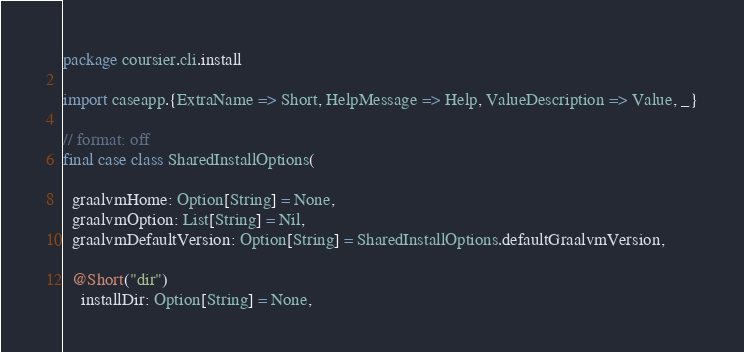Convert code to text. <code><loc_0><loc_0><loc_500><loc_500><_Scala_>package coursier.cli.install

import caseapp.{ExtraName => Short, HelpMessage => Help, ValueDescription => Value, _}

// format: off
final case class SharedInstallOptions(

  graalvmHome: Option[String] = None,
  graalvmOption: List[String] = Nil,
  graalvmDefaultVersion: Option[String] = SharedInstallOptions.defaultGraalvmVersion,

  @Short("dir")
    installDir: Option[String] = None,
</code> 